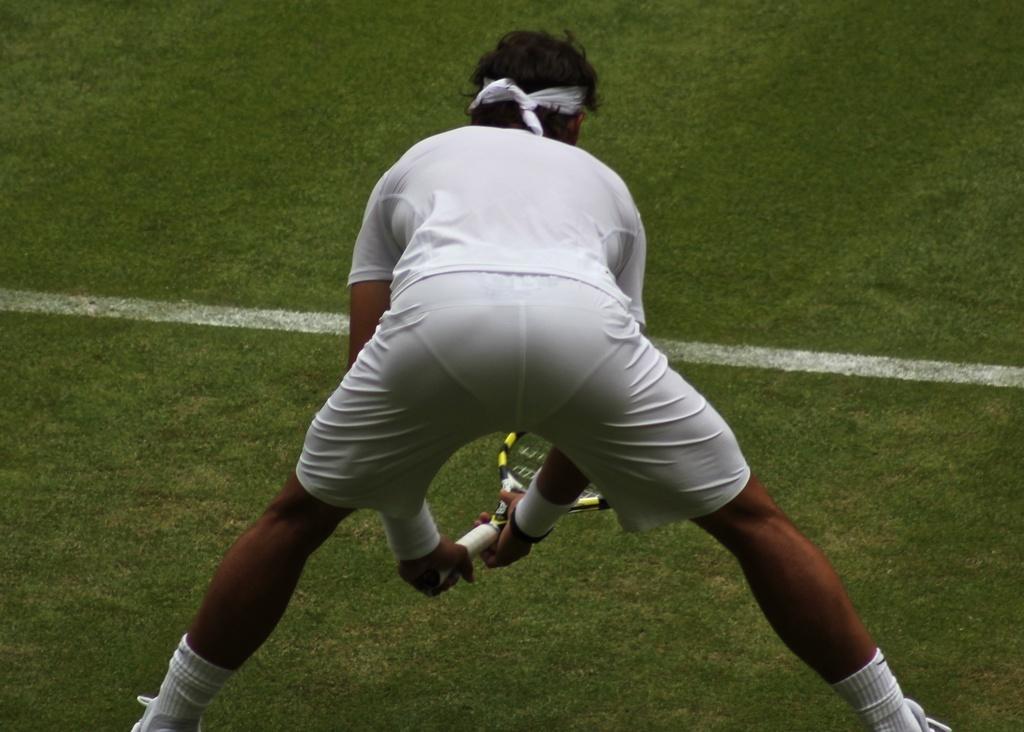In one or two sentences, can you explain what this image depicts? There is a person holding a racket and we can see grass in green color. 